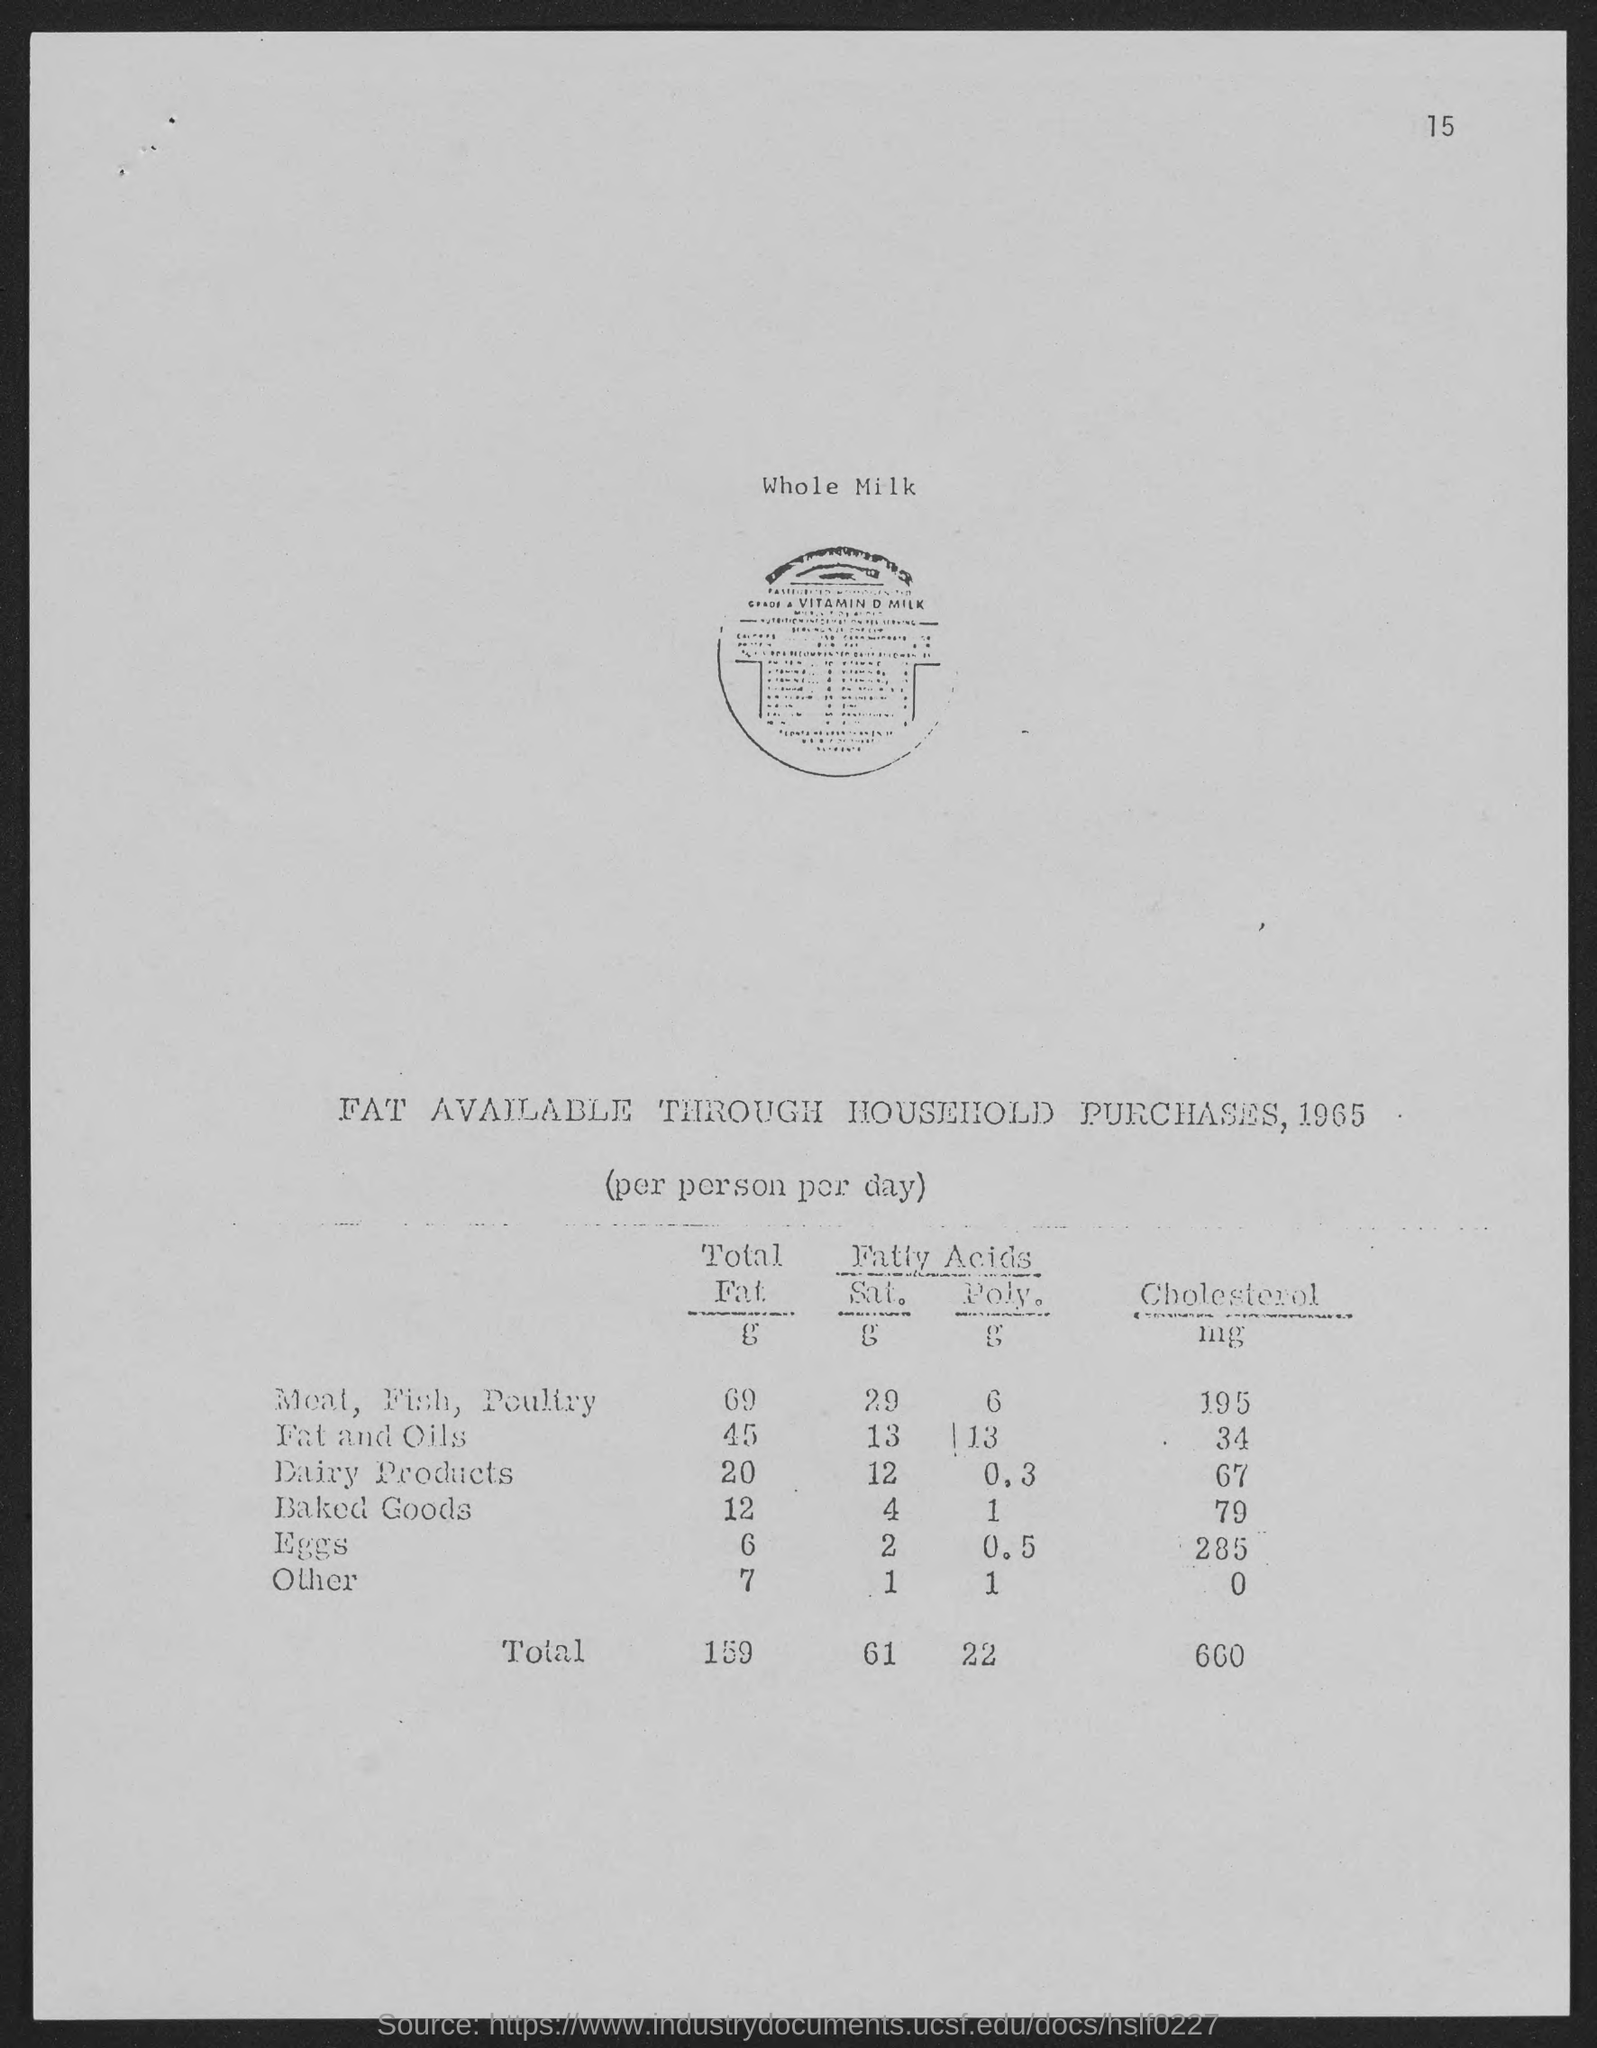Indicate a few pertinent items in this graphic. The first line of the document mentions the term "whole milk. The total value of cholesterol is 660. The document was compiled in 1965. The total fat content for dairy products is 20.. The product in the list with the highest cholesterol content is eggs. 